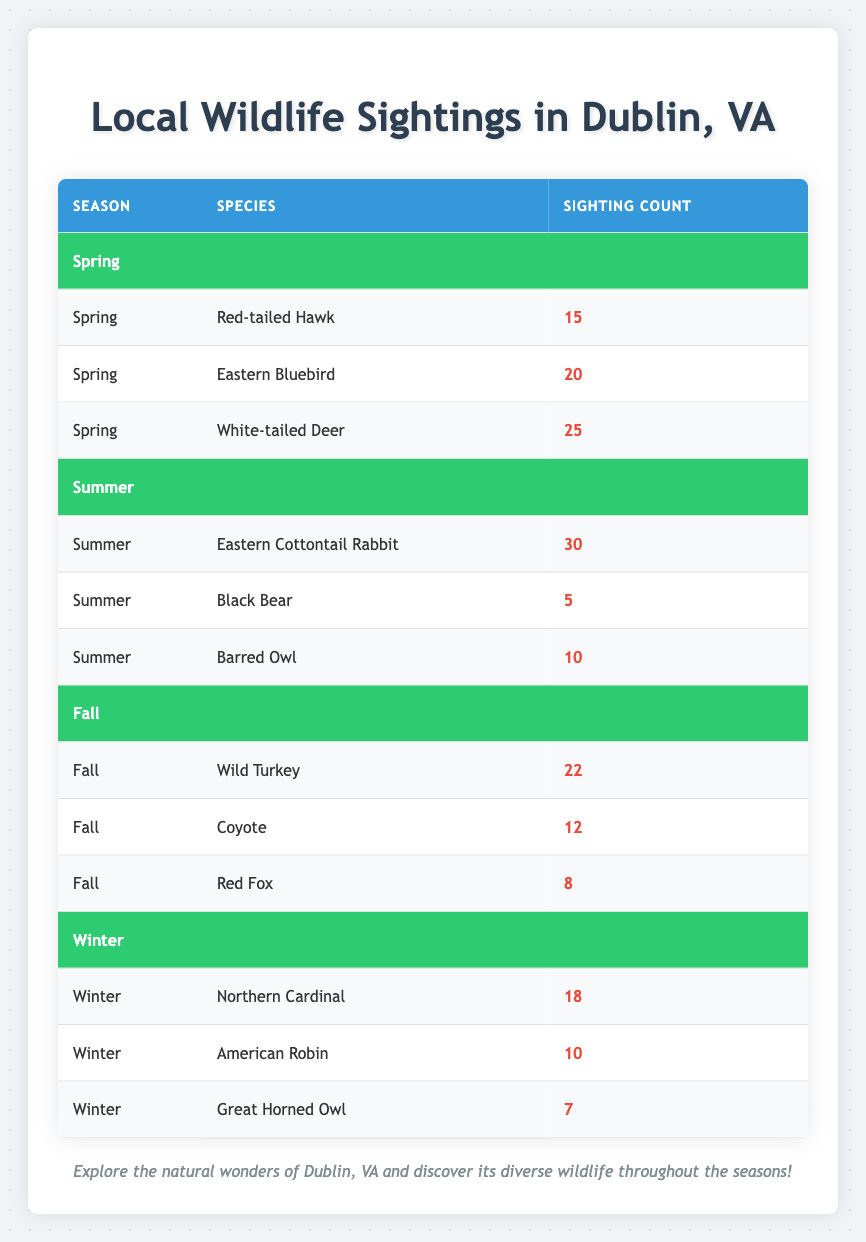What species had the highest sighting count in Spring? The table lists three species for Spring: Red-tailed Hawk (15), Eastern Bluebird (20), and White-tailed Deer (25). The species with the highest count is White-tailed Deer with 25 sightings.
Answer: White-tailed Deer How many species were sighted in Summer? The table shows three species for Summer: Eastern Cottontail Rabbit, Black Bear, and Barred Owl, making a total of 3 species.
Answer: 3 What is the total sighting count for Fall? To find the total for Fall, we sum the sightings: Wild Turkey (22) + Coyote (12) + Red Fox (8) = 42.
Answer: 42 Did the Black Bear have more sightings than the Barred Owl? The table indicates Black Bear had 5 sightings, while Barred Owl had 10. Since 5 is less than 10, the statement is false.
Answer: No What is the average sighting count for the Winter season? For Winter, the species sighted are Northern Cardinal (18), American Robin (10), and Great Horned Owl (7). The sum of sightings is 18 + 10 + 7 = 35. There are 3 species, so the average is 35 / 3 = approximately 11.67.
Answer: 11.67 Which season had the highest total wildlife sightings overall? We calculate the total sightings for each season: Spring = 15 + 20 + 25 = 60; Summer = 30 + 5 + 10 = 45; Fall = 22 + 12 + 8 = 42; Winter = 18 + 10 + 7 = 35. The highest total is for Spring with 60 sightings.
Answer: Spring Is the number of sightings for Northern Cardinal greater than the number of sightings for Red Fox? The Northern Cardinal sighting count is 18 and Red Fox has 8 sightings. Since 18 is greater than 8, the statement is true.
Answer: Yes How many more sightings were recorded for the Eastern Cottontail Rabbit compared to the Black Bear? The Eastern Cottontail Rabbit had 30 sightings and the Black Bear had 5 sightings. To find how many more, we calculate 30 - 5 = 25.
Answer: 25 